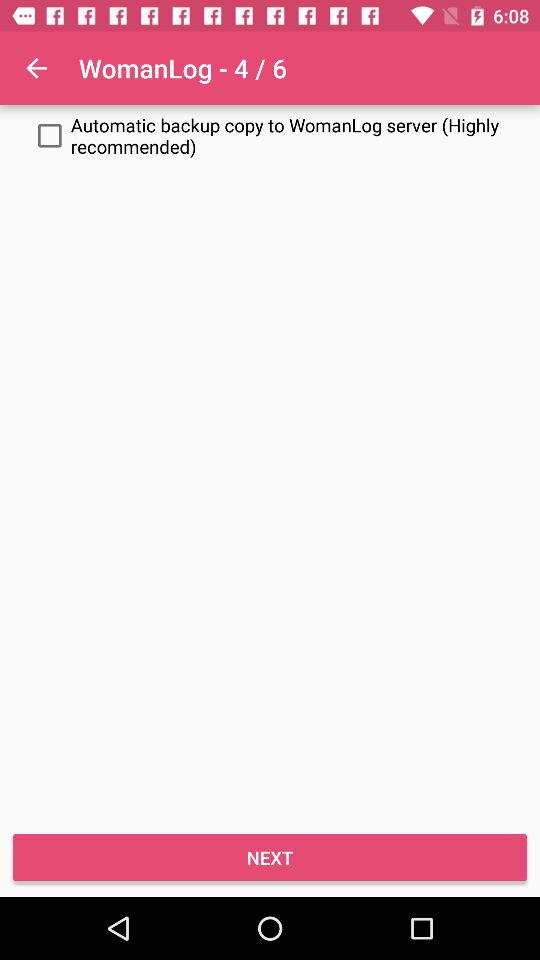How many pages are there in total for the WomanLog? There are a total of 6 pages. 